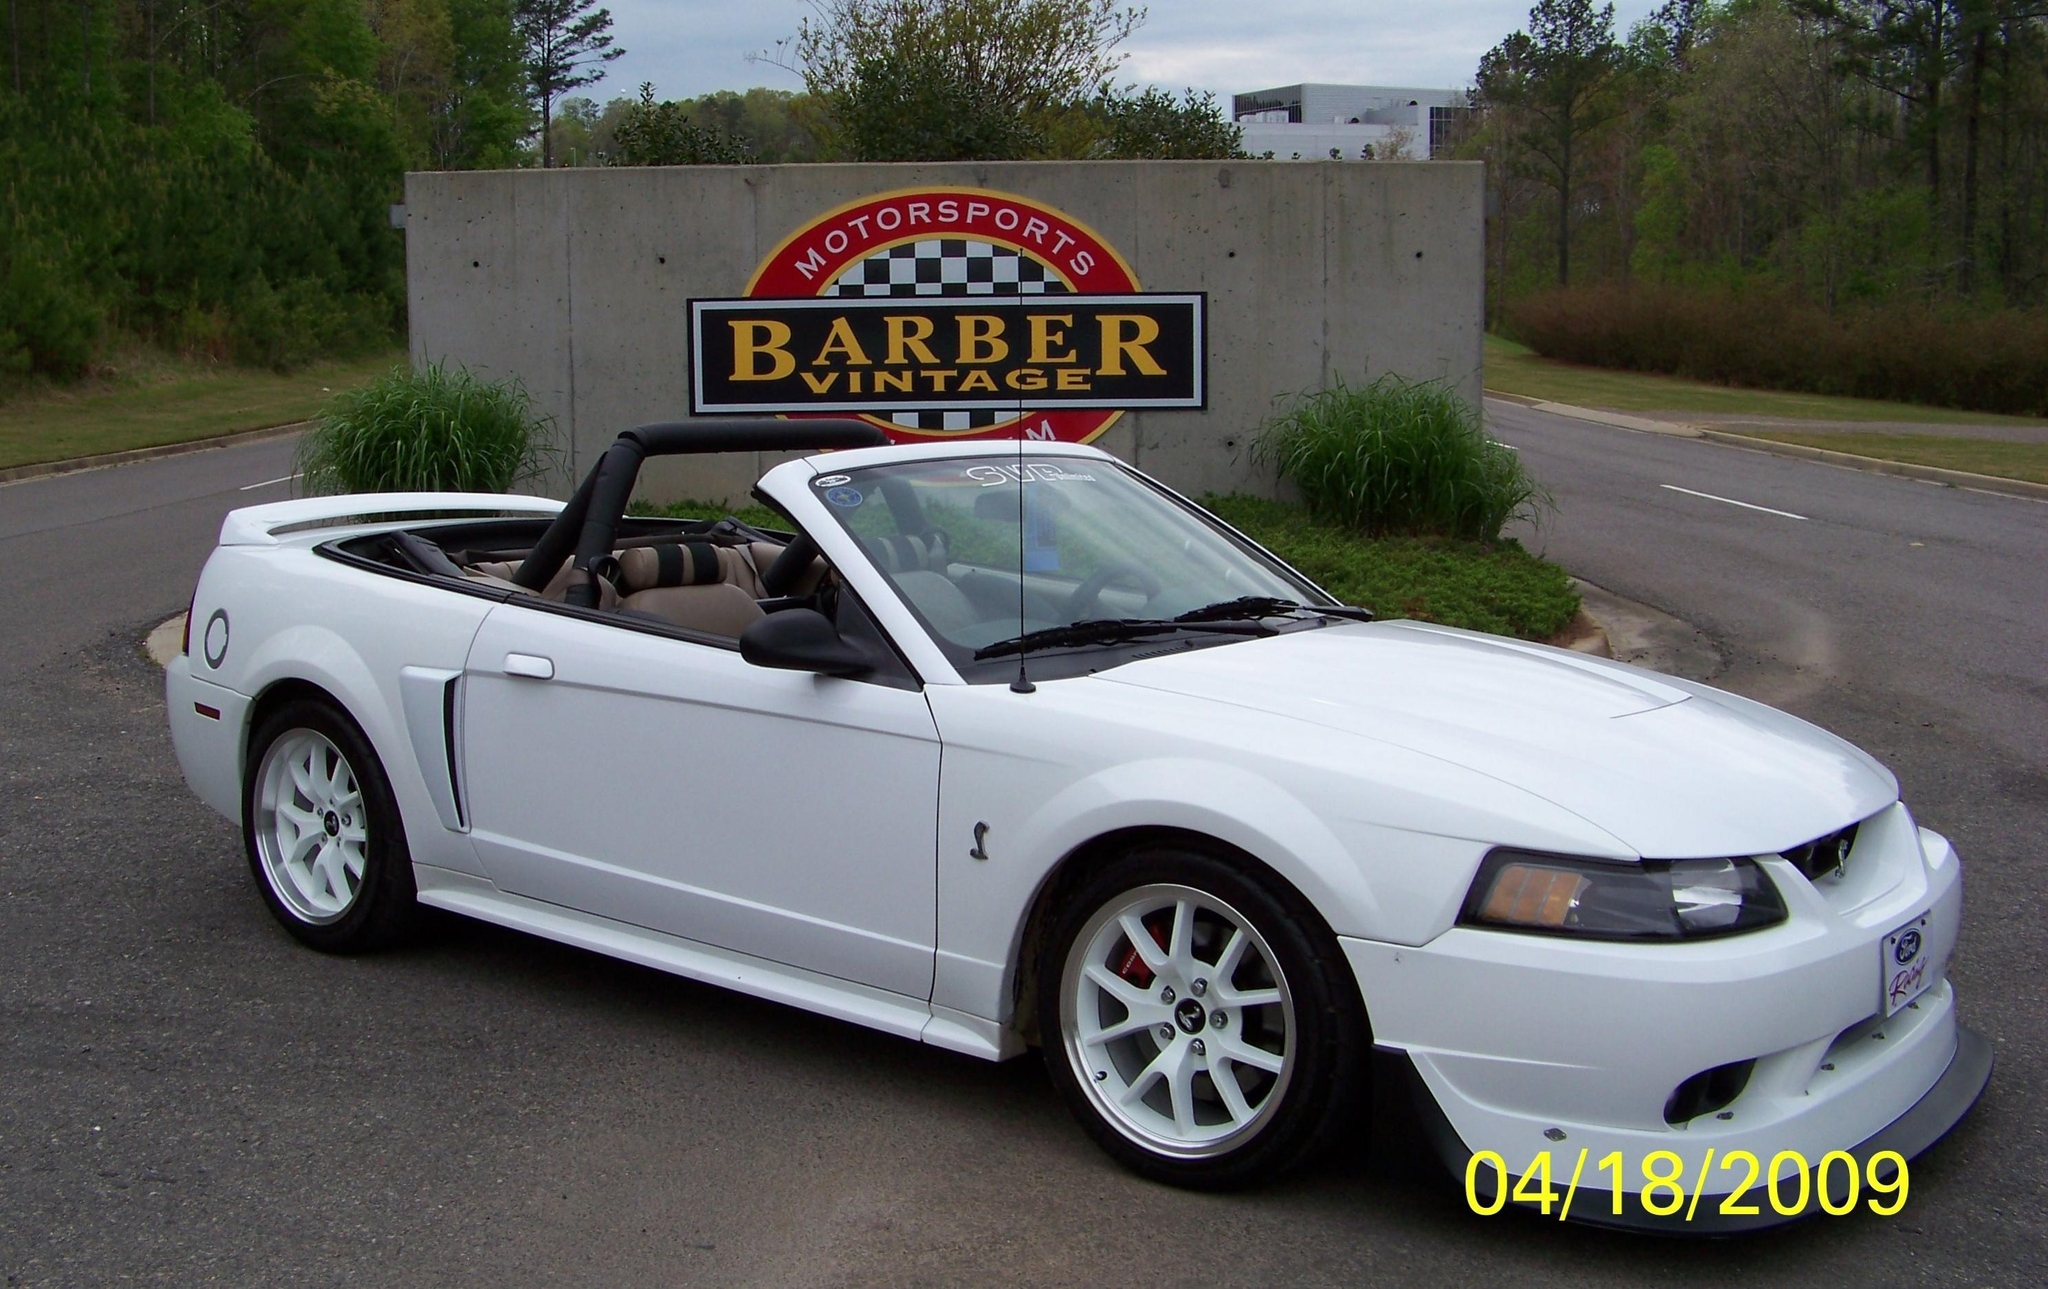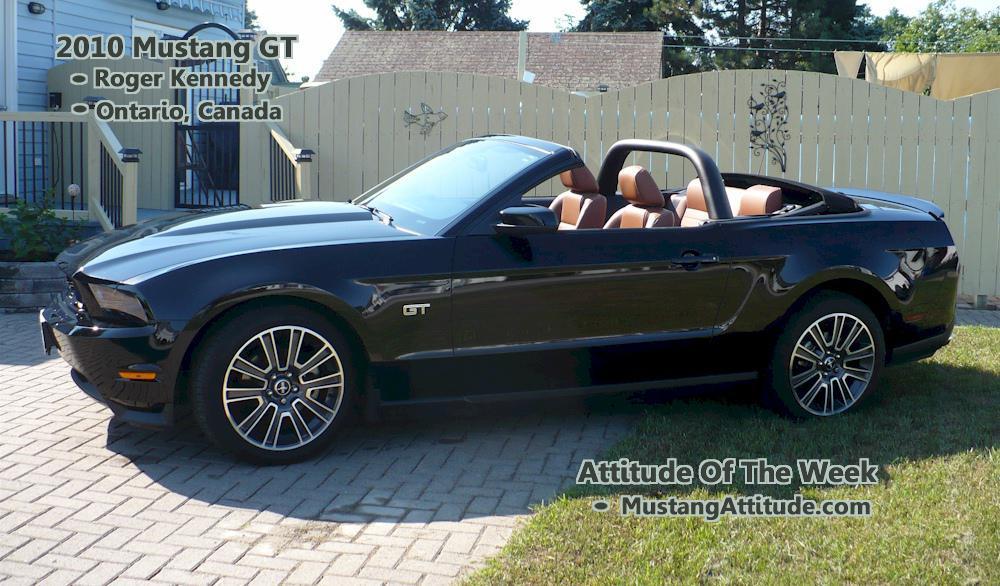The first image is the image on the left, the second image is the image on the right. Assess this claim about the two images: "An image shows a white topless convertible displayed parked at an angle on pavement.". Correct or not? Answer yes or no. Yes. The first image is the image on the left, the second image is the image on the right. Evaluate the accuracy of this statement regarding the images: "A white car is parked on the road in one of the images.". Is it true? Answer yes or no. Yes. 